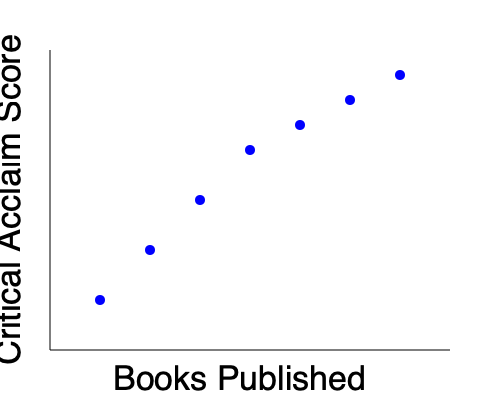Based on the scatter plot, what appears to be the relationship between an author's productivity (measured by the number of books published) and their critical acclaim? To analyze the relationship between an author's productivity and critical acclaim, we need to examine the pattern in the scatter plot:

1. Observe the overall trend: As we move from left to right (increasing number of books published), the points generally move upward (higher critical acclaim score).

2. Consistency of the trend: The upward trend is relatively consistent, with no significant outliers or clusters that deviate from the pattern.

3. Shape of the relationship: The points form a curve that rises steeply at first and then begins to level off as it moves to the right.

4. Interpretation: This pattern suggests a positive correlation between the number of books published and critical acclaim. However, the relationship appears to be non-linear, as the rate of increase in critical acclaim slows down as the number of books increases.

5. Possible explanation: Authors may gain more recognition and improve their craft as they publish more books, leading to higher critical acclaim. However, there might be a point of diminishing returns, where publishing additional books has less impact on their critical reception.

Given these observations, we can conclude that there is a positive, non-linear relationship between an author's productivity and critical acclaim, with the impact of additional publications diminishing at higher levels of productivity.
Answer: Positive, non-linear relationship with diminishing returns 